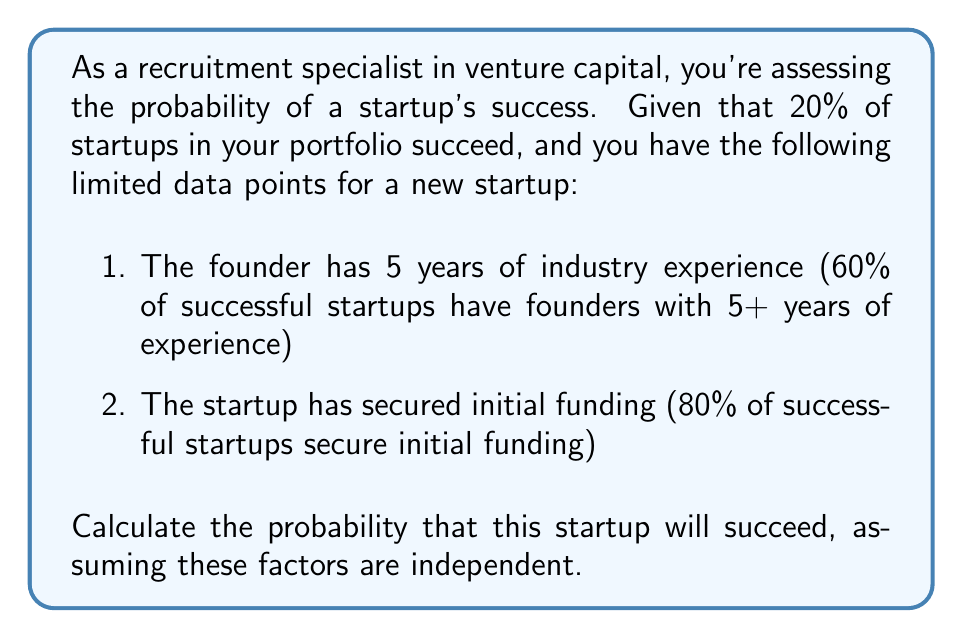Can you solve this math problem? Let's approach this problem using Bayes' Theorem and the given information:

1. Define events:
   S: Startup succeeds
   E: Founder has 5+ years of experience
   F: Startup secured initial funding

2. Given probabilities:
   P(S) = 0.20 (prior probability of success)
   P(E|S) = 0.60 (probability of 5+ years experience given success)
   P(F|S) = 0.80 (probability of initial funding given success)

3. We need to calculate P(S|E,F) using Bayes' Theorem:

   $$P(S|E,F) = \frac{P(E,F|S) \cdot P(S)}{P(E,F)}$$

4. Assuming independence of E and F:
   
   $$P(E,F|S) = P(E|S) \cdot P(F|S) = 0.60 \cdot 0.80 = 0.48$$

5. Calculate P(E,F):
   
   $$P(E,F) = P(E,F|S) \cdot P(S) + P(E,F|\text{not S}) \cdot P(\text{not S})$$

   We need P(E,F|not S):
   
   $$P(E|S) = 0.60 = \frac{P(S|E) \cdot P(E)}{P(S)} = \frac{P(S|E) \cdot P(E)}{0.20}$$
   $$P(E) = 0.20 \cdot 0.60 / P(S|E)$$

   Similarly for F:
   $$P(F) = 0.20 \cdot 0.80 / P(S|F)$$

   Assuming P(S|E) and P(S|F) are both greater than 0.20 (as these factors increase success probability), let's estimate P(E) ≈ 0.30 and P(F) ≈ 0.40.

   Then, P(E,F|not S) ≈ 0.30 * 0.40 = 0.12 (assuming independence)

   $$P(E,F) = 0.48 \cdot 0.20 + 0.12 \cdot 0.80 = 0.096 + 0.096 = 0.192$$

6. Now we can calculate P(S|E,F):

   $$P(S|E,F) = \frac{0.48 \cdot 0.20}{0.192} = 0.50$$
Answer: 0.50 or 50% 